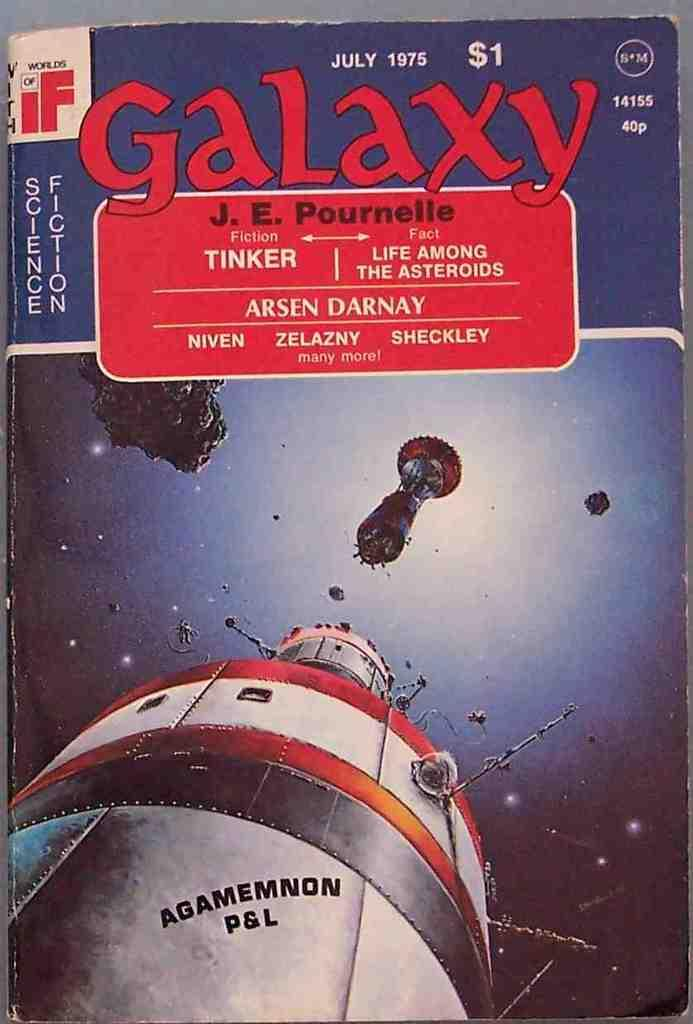<image>
Summarize the visual content of the image. A book is dated July 1975 and has a one dollar price tag. 